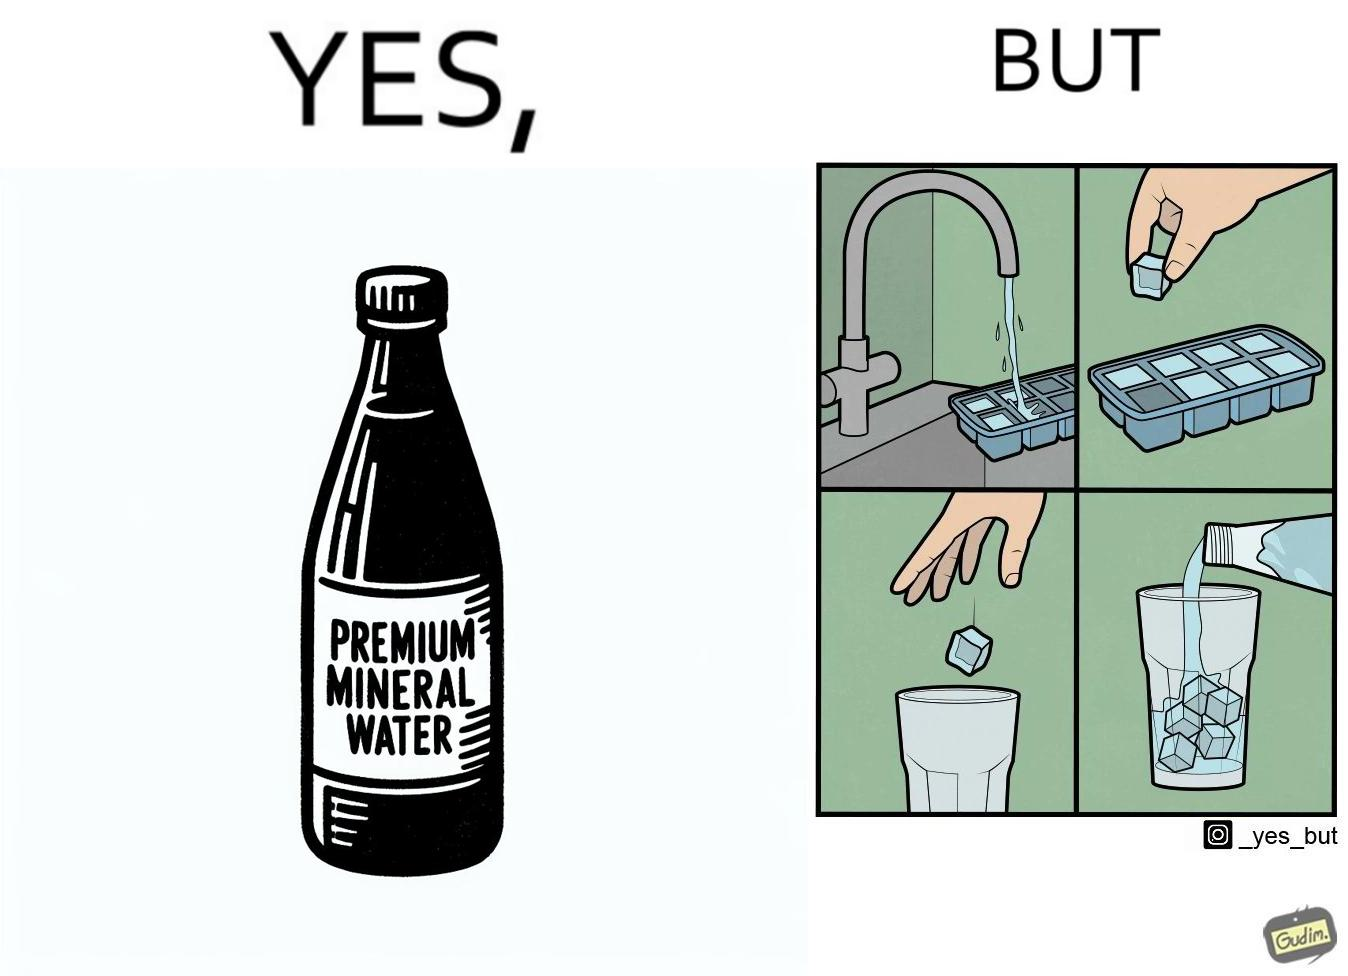Describe the contrast between the left and right parts of this image. In the left part of the image: A bottle of "Premium Mineral Water". In the right part of the image: Pouring a bottle of water into a glass having ice cubes formed by refrigerating tap water. 